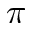Convert formula to latex. <formula><loc_0><loc_0><loc_500><loc_500>\pi</formula> 